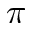Convert formula to latex. <formula><loc_0><loc_0><loc_500><loc_500>\pi</formula> 